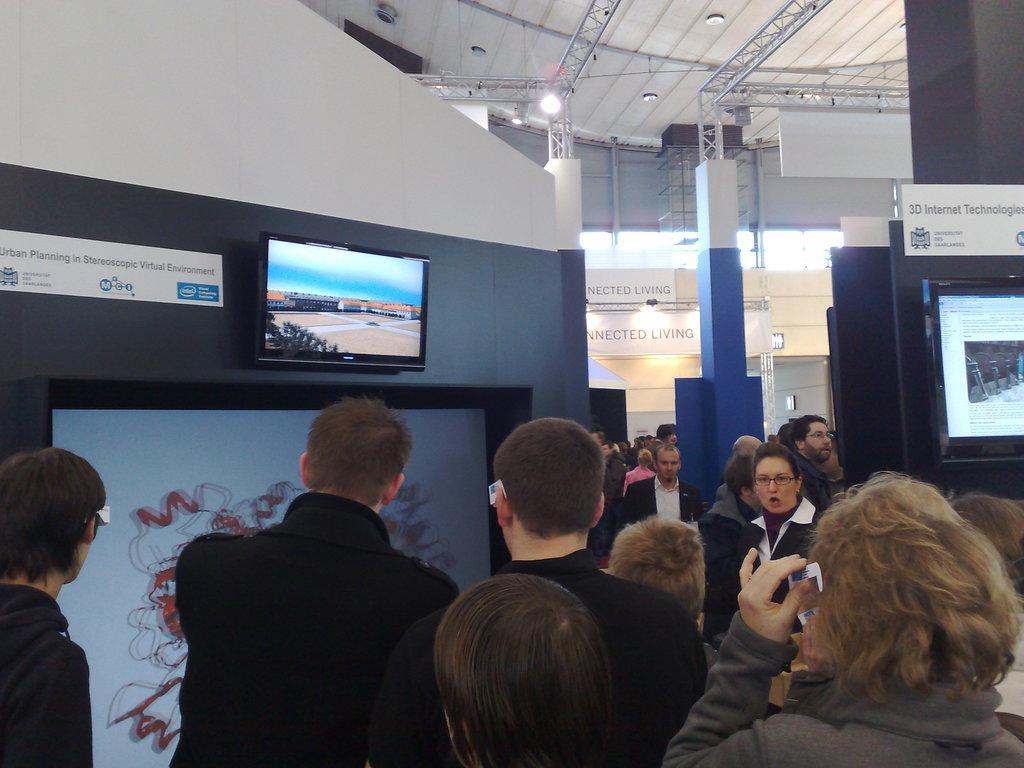Please provide a concise description of this image. In this image I can see a group of people are standing on the floor, screens, wall and pillars. In the background I can see boards, metal rods and lights on a rooftop. This image is taken may be in a hall. 